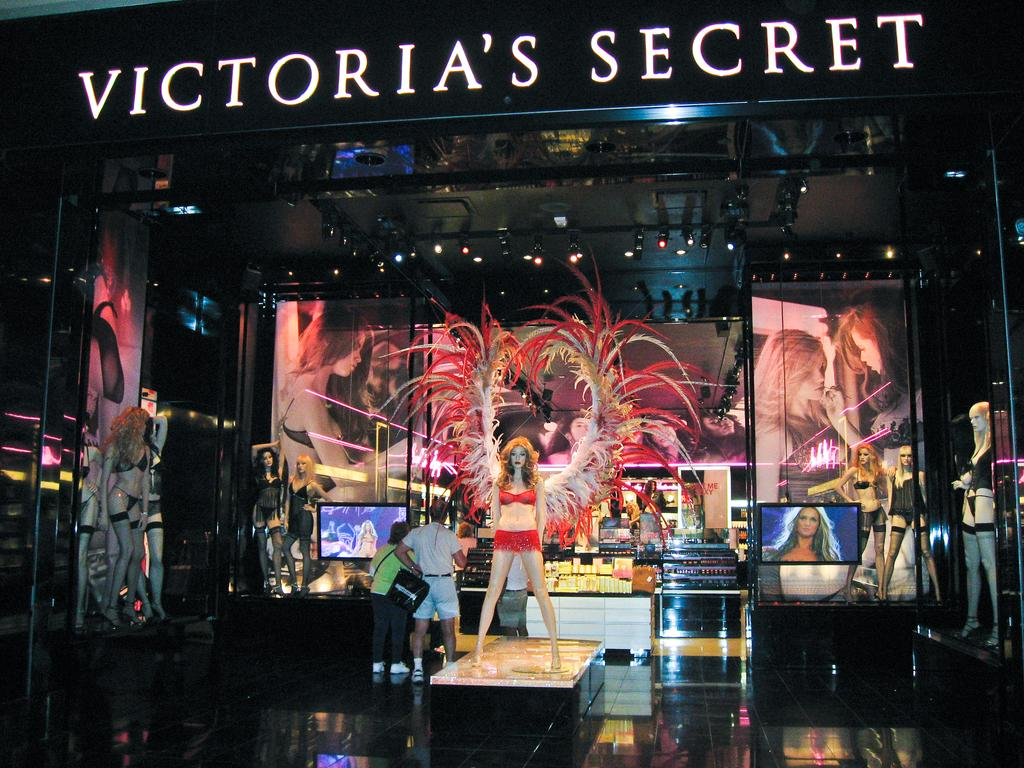What is the main subject in the center of the image? There is a lady wearing a costume in the center of the image. What can be seen in the background of the image? There are screens, lights, people, and mannequins in the background of the image. What type of metal is used to create the wax figures in the image? There are no wax figures present in the image. 